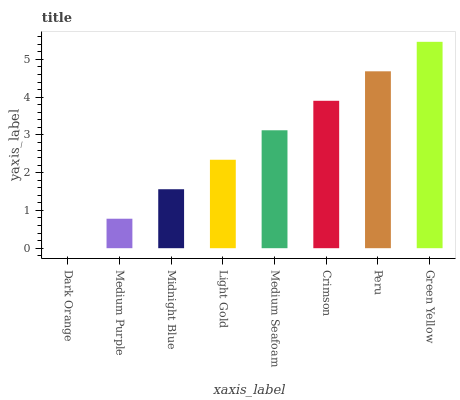Is Medium Purple the minimum?
Answer yes or no. No. Is Medium Purple the maximum?
Answer yes or no. No. Is Medium Purple greater than Dark Orange?
Answer yes or no. Yes. Is Dark Orange less than Medium Purple?
Answer yes or no. Yes. Is Dark Orange greater than Medium Purple?
Answer yes or no. No. Is Medium Purple less than Dark Orange?
Answer yes or no. No. Is Medium Seafoam the high median?
Answer yes or no. Yes. Is Light Gold the low median?
Answer yes or no. Yes. Is Dark Orange the high median?
Answer yes or no. No. Is Midnight Blue the low median?
Answer yes or no. No. 